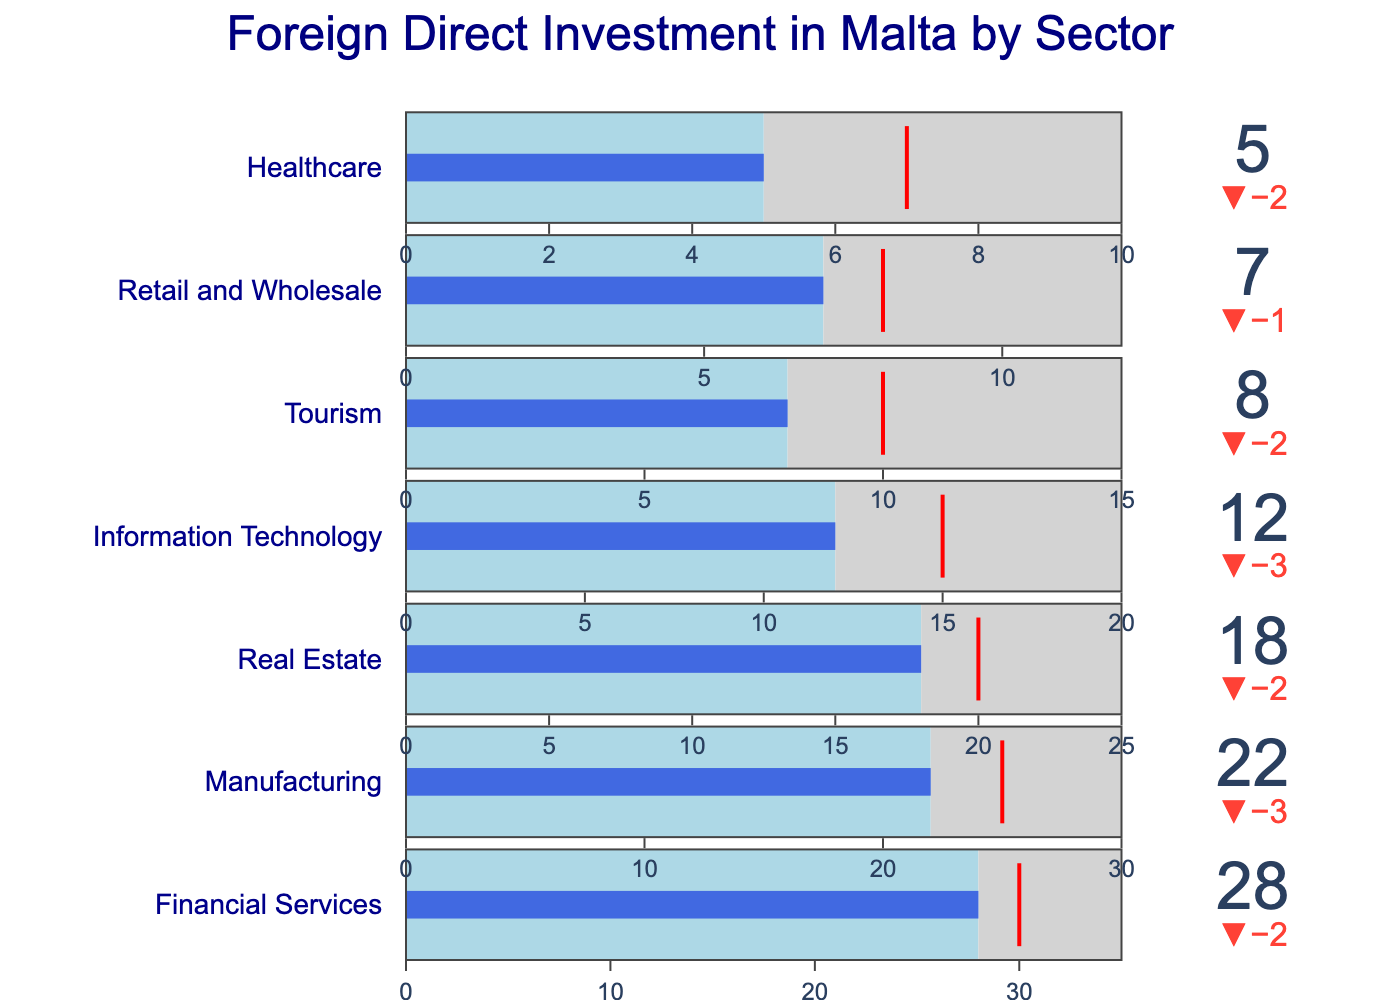How many sectors are represented in the chart? By counting the distinct titles for each sector in the chart, we identify there are seven different sectors represented.
Answer: Seven What is the percentage of FDI in the Information Technology sector? The figure shows a bullet chart with the title "Information Technology" and indicates an actual FDI value of 12%.
Answer: 12% Which sector has the highest target FDI? By reviewing the target FDI values for all sectors, the Financial Services sector stands out with the highest target at 30%.
Answer: Financial Services Are there any sectors where the actual FDI exceeds the target FDI? To find such sectors, we need to compare the actual and target FDI values for each sector. No sector has actual FDI exceeding the target FDI in this figure.
Answer: No What is the difference between the maximum FDI and the target FDI for the Retail and Wholesale sector? The maximum FDI is 12%, and the target FDI is 8%. The difference is calculated as 12% - 8% which equals 4%.
Answer: 4% Which sector is furthest below its target FDI in both absolute and relative terms? By examining each sector, the Tourism sector with an actual FDI of 8% and a target of 10% is 2% below its target, and in relative terms (2/10), it is 20% below. No other sector exceeds this in relative terms.
Answer: Tourism How does the actual FDI in Manufacturing compare to Information Technology? The actual FDI in Manufacturing is 22%, while in Information Technology it is 12%. The Manufacturing sector has a higher actual FDI.
Answer: Higher Which sector is closest to meeting its target FDI? By comparing the differences between actual and target FDIs across sectors, the Financial Services sector, with an actual FDI of 28% and a target of 30%, is only 2% below its target.
Answer: Financial Services What percentage of the maximum FDI is the actual FDI in the Healthcare sector? The actual FDI in Healthcare is 5%, and the maximum FDI is 10%. The percentage is calculated as (5/10) * 100%, equating to 50%.
Answer: 50% Is there any sector with an actual FDI value exactly half of its maximum FDI value? By evaluating the actual and maximum FDIs, Healthcare falls into this category with an actual FDI of 5% and a maximum FDI of 10%.
Answer: Healthcare 